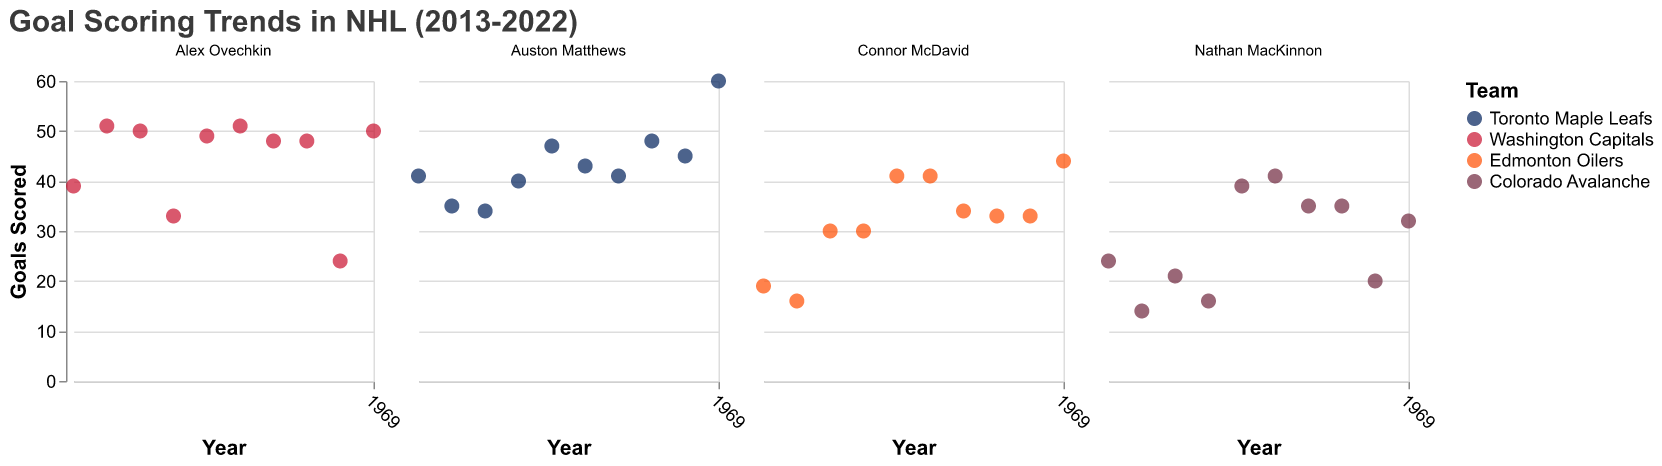What is the title of the figure? The title can be seen at the top of the figure. It reads "Goal Scoring Trends in NHL (2013-2022)".
Answer: Goal Scoring Trends in NHL (2013-2022) Which player has the highest single-season goal total? By examining the scatter plots for each player, Auston Matthews's point for the year 2022 shows the highest single-season goal total with 60 goals.
Answer: Auston Matthews How many goals did Alex Ovechkin score in 2014? Find Alex Ovechkin's subplot and check the point corresponding to the year 2014. It indicates he scored 51 goals.
Answer: 51 Compare the goal-scoring trends of Auston Matthews and Nathan MacKinnon from 2017 to 2022. Who scored more total goals in this period? Sum Auston Matthews's goals from 2017 to 2022 (47+43+41+48+45+60=284) and Nathan MacKinnon's goals from 2017 to 2022 (39+41+35+35+20+32=202). Matthews scored 284 goals, and MacKinnon scored 202.
Answer: Auston Matthews Which player showed the greatest improvement in goals from 2021 to 2022? By observing the goal counts from 2021 to 2022, Auston Matthews's goals increased from 45 to 60, an improvement of 15 goals. Other players show smaller differences.
Answer: Auston Matthews How did Connor McDavid's goal total change from 2013 to 2014? Find the points for Connor McDavid in 2013 and 2014. His goal total decreased from 19 to 16, a reduction of 3 goals.
Answer: Decreased by 3 goals Which team represented by color has the player with the highest goals in a single year? The team colors are distinct, with Toronto Maple Leafs (blue), Washington Capitals (red), Edmonton Oilers (orange), and Colorado Avalanche (purple). Auston Matthews from Toronto Maple Leafs (blue) has the highest single-season goal total with 60 goals in 2022.
Answer: Toronto Maple Leafs What was the average number of goals scored by Alex Ovechkin from 2013 to 2022? Calculate the average by adding Ovechkin's goals from 2013 to 2022 (39+51+50+33+49+51+48+48+24+50) and divide by the number of years (10). The sum is 443, and the average is 443/10 = 44.3.
Answer: 44.3 Which player had the most consistent goal-scoring performance (the least variation) from 2013 to 2022? Examine the variation in goals for each player across the years. Connor McDavid's goals range from 16 to 44, showing less fluctuation compared to others.
Answer: Connor McDavid How many goals did Nathan MacKinnon score in total from 2013 to 2022? Add Nathan MacKinnon's goals from 2013 to 2022: 24+14+21+16+39+41+35+35+20+32. The sum totals 277 goals.
Answer: 277 